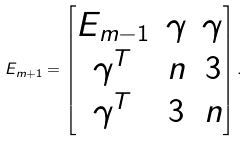<formula> <loc_0><loc_0><loc_500><loc_500>E _ { m + 1 } = \begin{bmatrix} E _ { m - 1 } & \gamma & \gamma \\ \gamma ^ { T } & n & 3 \\ \gamma ^ { T } & 3 & n \end{bmatrix} .</formula> 